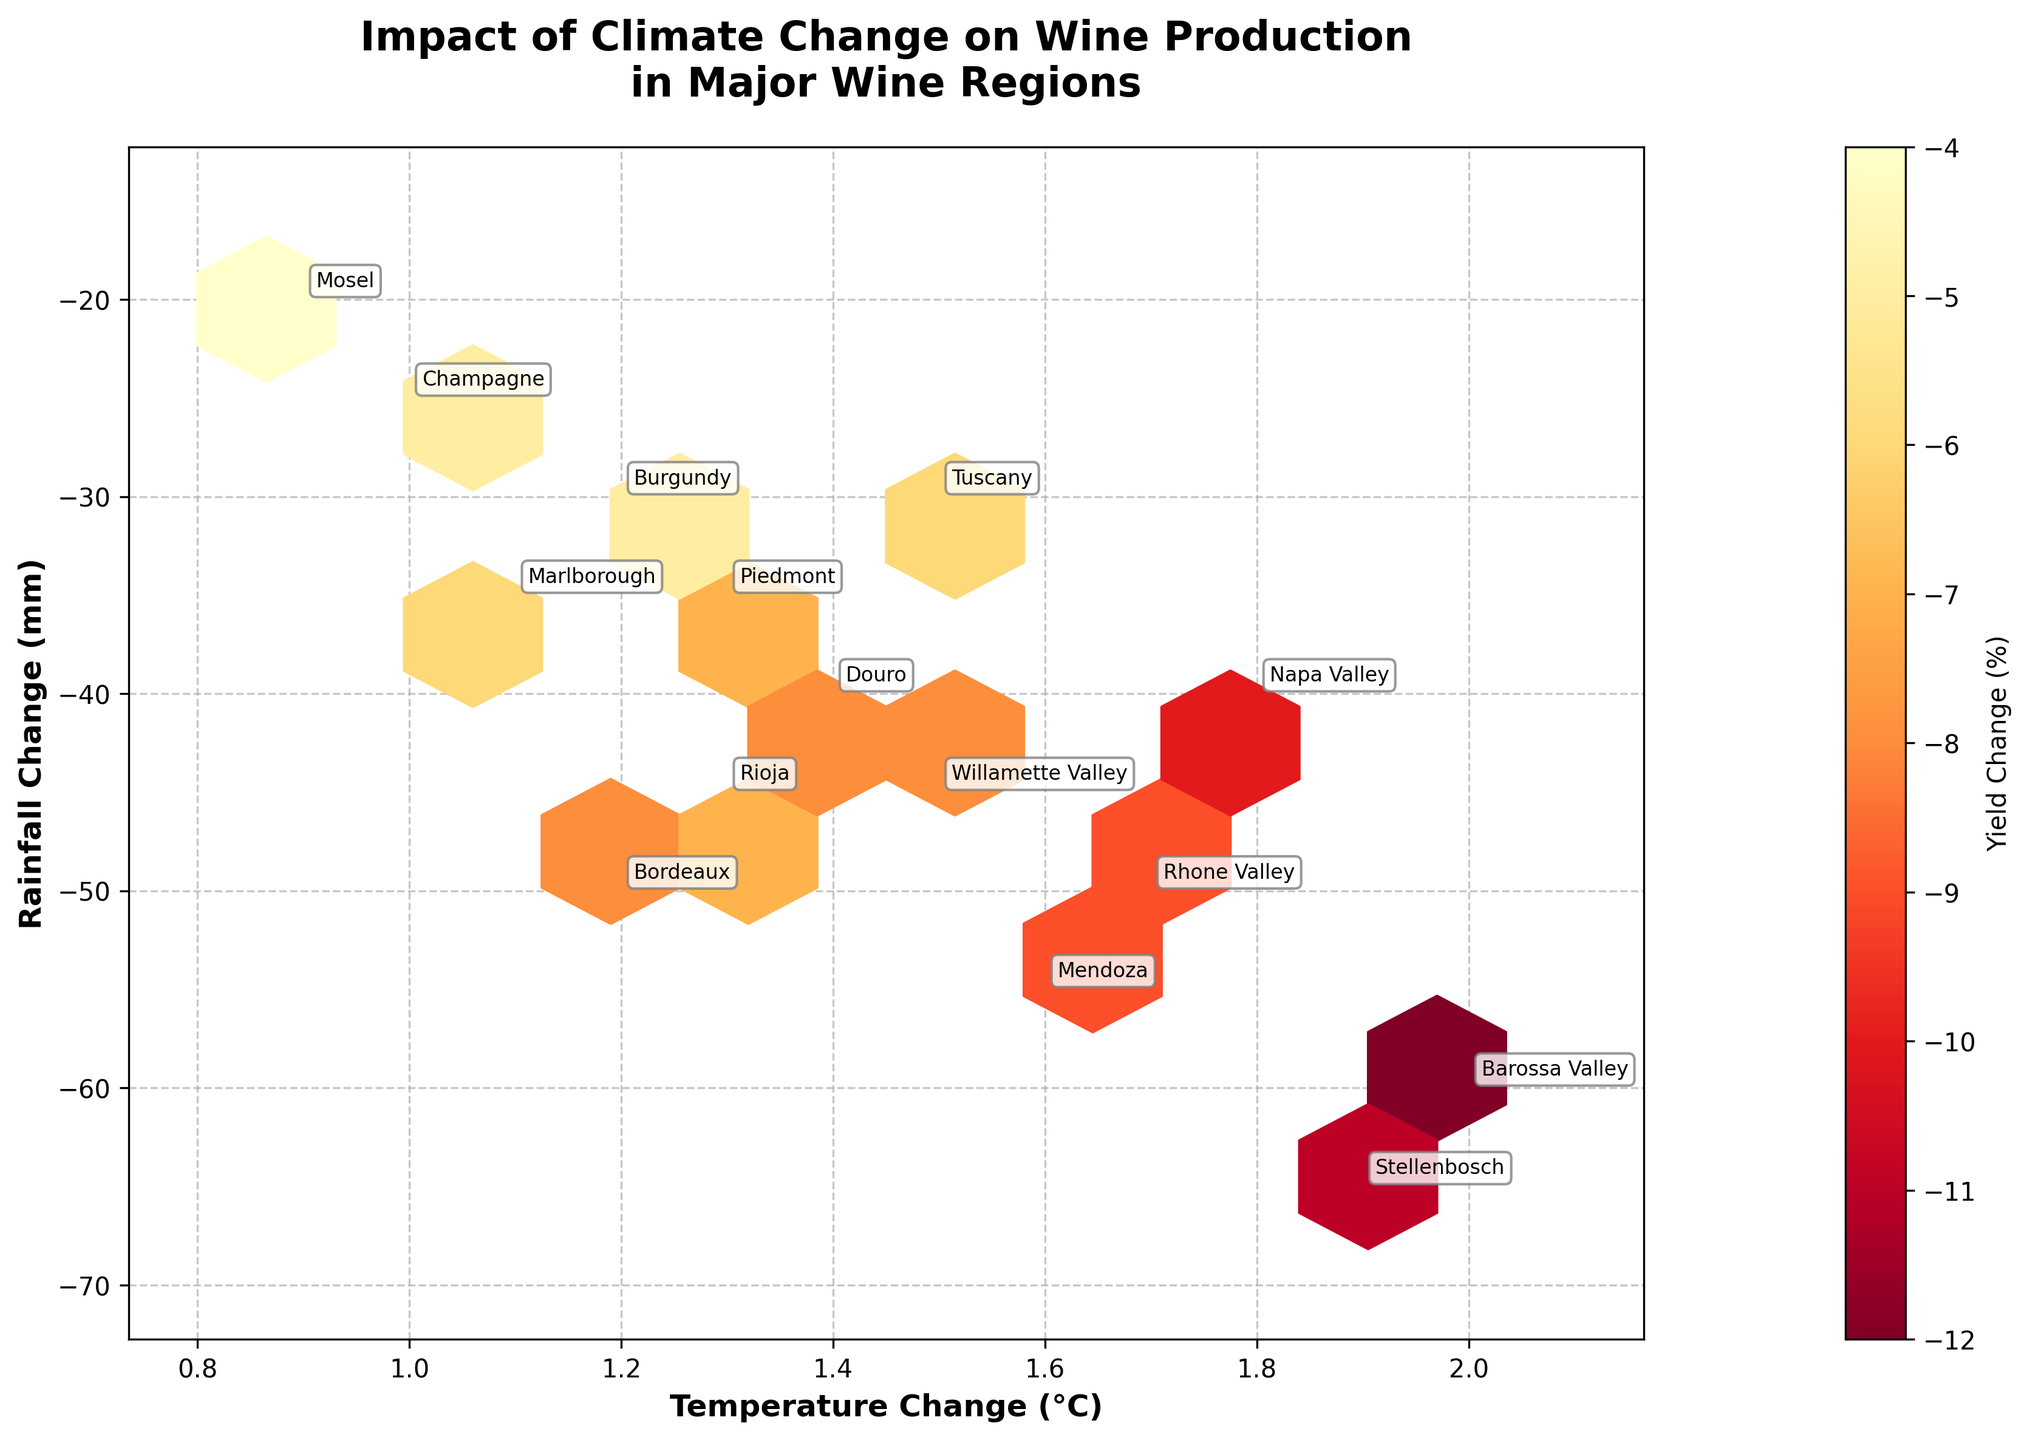What is the title of the figure? The title of the figure is prominently displayed at the top and reads "Impact of Climate Change on Wine Production\nin Major Wine Regions".
Answer: Impact of Climate Change on Wine Production\nin Major Wine Regions What does the color in the hexbin plot represent? The color of each hexbin in the plot represents the yield change percentage for wine production in the regions, as indicated by the color bar on the right labeled "Yield Change (%)".
Answer: Yield Change (%) Which region has the highest temperature change? By observing the plot, "Barossa Valley" has the highest temperature change of 2.0°C.
Answer: Barossa Valley Which regions have the same rainfall change? The regions "Napa Valley" and "Douro" both have a rainfall change of -40 mm.
Answer: Napa Valley, Douro How does temperature change correlate with yield change? To determine this, look at the hexbin plot where clusters indicate the concentration of data. Regions with higher temperature changes generally show more negative yield changes based on the color intensity. More intense colors (darker) represent more negative yield changes, suggesting a negative correlation.
Answer: Negative correlation How many regions experienced a yield change percentage of -8%? By inspecting the color bar and the annotations, the regions "Bordeaux", "Douro", and "Willamette Valley" each show a yield change of -8%.
Answer: 3 Which region experienced the most significant decrease in rainfall? "Stellenbosch" experienced the most significant decrease in rainfall with -65 mm.
Answer: Stellenbosch Is there any region with a temperature change below 1.0°C? Yes, "Mosel" has a temperature change below 1.0°C at 0.9°C.
Answer: Mosel What can you infer about regions with higher temperature changes and their corresponding yield changes? Regions with higher temperature changes tend to have higher negative yield changes. For example, "Barossa Valley" with 2.0°C temperature change has a significant yield decrease of -12%. This suggests a possible trend that higher temperatures negatively impact yields.
Answer: Higher temperature changes lead to higher negative yield changes Which region has the least impact on yield change and what are its temperature and rainfall changes? "Mosel" has the least impact on yield change with -4%. It experienced a temperature change of 0.9°C and a rainfall change of -20 mm.
Answer: Mosel (Temperature: 0.9°C, Rainfall: -20 mm) 